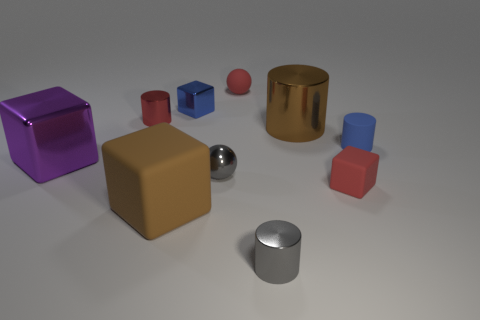Subtract all green cubes. Subtract all gray balls. How many cubes are left? 4 Subtract all cylinders. How many objects are left? 6 Add 8 small green rubber cubes. How many small green rubber cubes exist? 8 Subtract 1 brown cylinders. How many objects are left? 9 Subtract all red metal things. Subtract all purple shiny cubes. How many objects are left? 8 Add 9 red cylinders. How many red cylinders are left? 10 